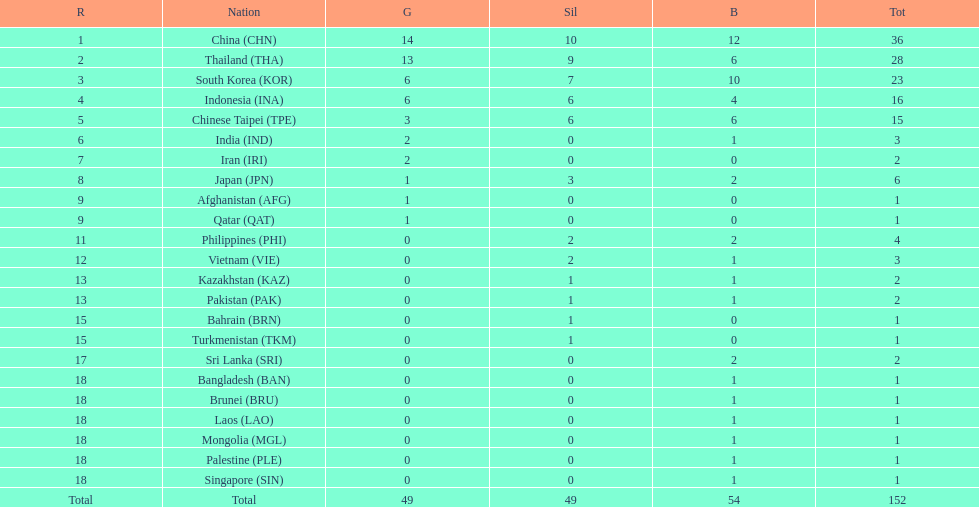What is the total number of nations that participated in the beach games of 2012? 23. 